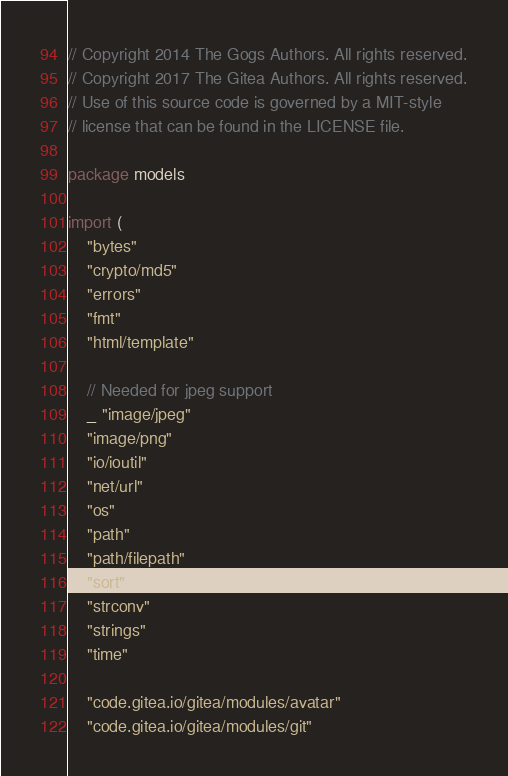<code> <loc_0><loc_0><loc_500><loc_500><_Go_>// Copyright 2014 The Gogs Authors. All rights reserved.
// Copyright 2017 The Gitea Authors. All rights reserved.
// Use of this source code is governed by a MIT-style
// license that can be found in the LICENSE file.

package models

import (
	"bytes"
	"crypto/md5"
	"errors"
	"fmt"
	"html/template"

	// Needed for jpeg support
	_ "image/jpeg"
	"image/png"
	"io/ioutil"
	"net/url"
	"os"
	"path"
	"path/filepath"
	"sort"
	"strconv"
	"strings"
	"time"

	"code.gitea.io/gitea/modules/avatar"
	"code.gitea.io/gitea/modules/git"</code> 